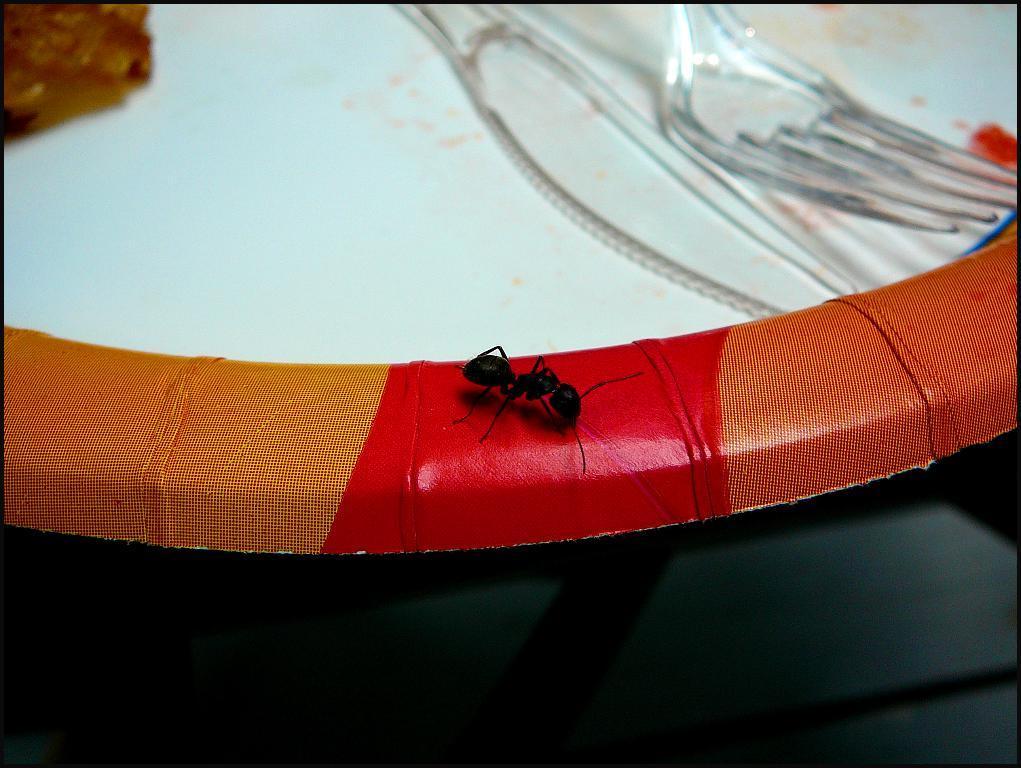How would you summarize this image in a sentence or two? In this image there is a plate, knife, fork and an object. We can see an ant on the plate. 